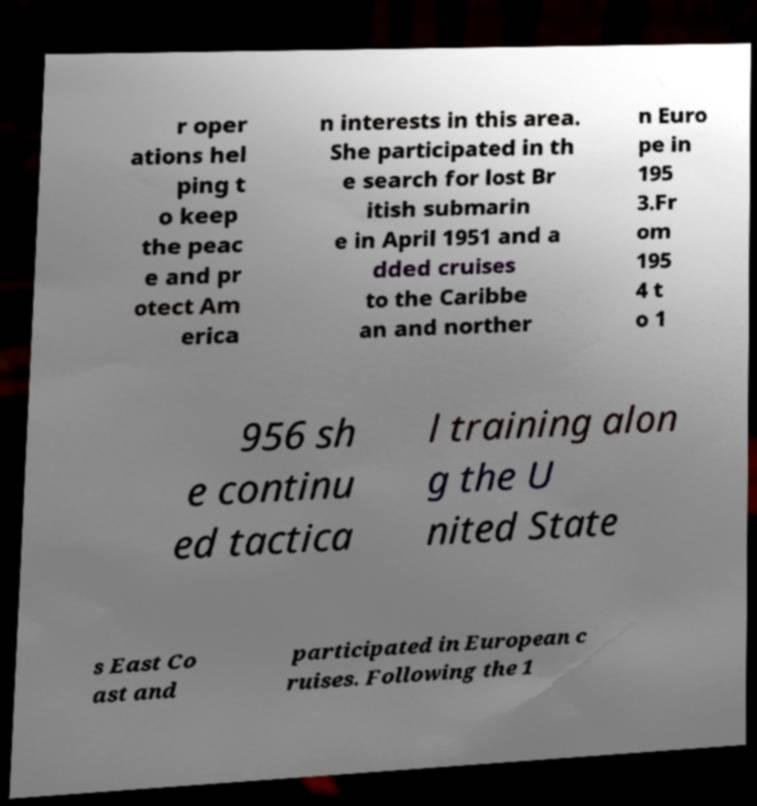For documentation purposes, I need the text within this image transcribed. Could you provide that? r oper ations hel ping t o keep the peac e and pr otect Am erica n interests in this area. She participated in th e search for lost Br itish submarin e in April 1951 and a dded cruises to the Caribbe an and norther n Euro pe in 195 3.Fr om 195 4 t o 1 956 sh e continu ed tactica l training alon g the U nited State s East Co ast and participated in European c ruises. Following the 1 